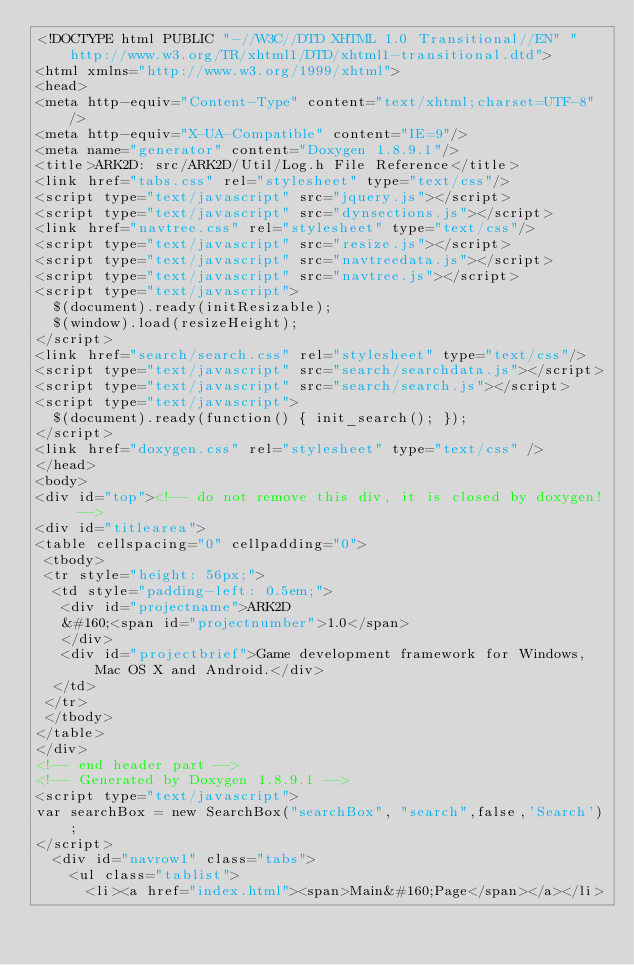Convert code to text. <code><loc_0><loc_0><loc_500><loc_500><_HTML_><!DOCTYPE html PUBLIC "-//W3C//DTD XHTML 1.0 Transitional//EN" "http://www.w3.org/TR/xhtml1/DTD/xhtml1-transitional.dtd">
<html xmlns="http://www.w3.org/1999/xhtml">
<head>
<meta http-equiv="Content-Type" content="text/xhtml;charset=UTF-8"/>
<meta http-equiv="X-UA-Compatible" content="IE=9"/>
<meta name="generator" content="Doxygen 1.8.9.1"/>
<title>ARK2D: src/ARK2D/Util/Log.h File Reference</title>
<link href="tabs.css" rel="stylesheet" type="text/css"/>
<script type="text/javascript" src="jquery.js"></script>
<script type="text/javascript" src="dynsections.js"></script>
<link href="navtree.css" rel="stylesheet" type="text/css"/>
<script type="text/javascript" src="resize.js"></script>
<script type="text/javascript" src="navtreedata.js"></script>
<script type="text/javascript" src="navtree.js"></script>
<script type="text/javascript">
  $(document).ready(initResizable);
  $(window).load(resizeHeight);
</script>
<link href="search/search.css" rel="stylesheet" type="text/css"/>
<script type="text/javascript" src="search/searchdata.js"></script>
<script type="text/javascript" src="search/search.js"></script>
<script type="text/javascript">
  $(document).ready(function() { init_search(); });
</script>
<link href="doxygen.css" rel="stylesheet" type="text/css" />
</head>
<body>
<div id="top"><!-- do not remove this div, it is closed by doxygen! -->
<div id="titlearea">
<table cellspacing="0" cellpadding="0">
 <tbody>
 <tr style="height: 56px;">
  <td style="padding-left: 0.5em;">
   <div id="projectname">ARK2D
   &#160;<span id="projectnumber">1.0</span>
   </div>
   <div id="projectbrief">Game development framework for Windows, Mac OS X and Android.</div>
  </td>
 </tr>
 </tbody>
</table>
</div>
<!-- end header part -->
<!-- Generated by Doxygen 1.8.9.1 -->
<script type="text/javascript">
var searchBox = new SearchBox("searchBox", "search",false,'Search');
</script>
  <div id="navrow1" class="tabs">
    <ul class="tablist">
      <li><a href="index.html"><span>Main&#160;Page</span></a></li></code> 